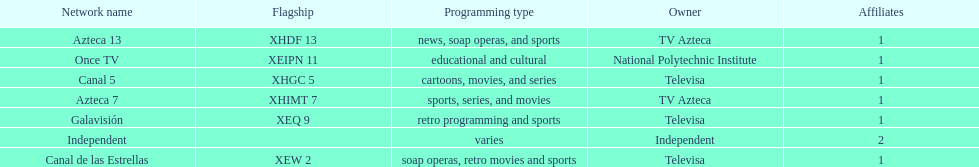How many networks do not air sports? 2. 